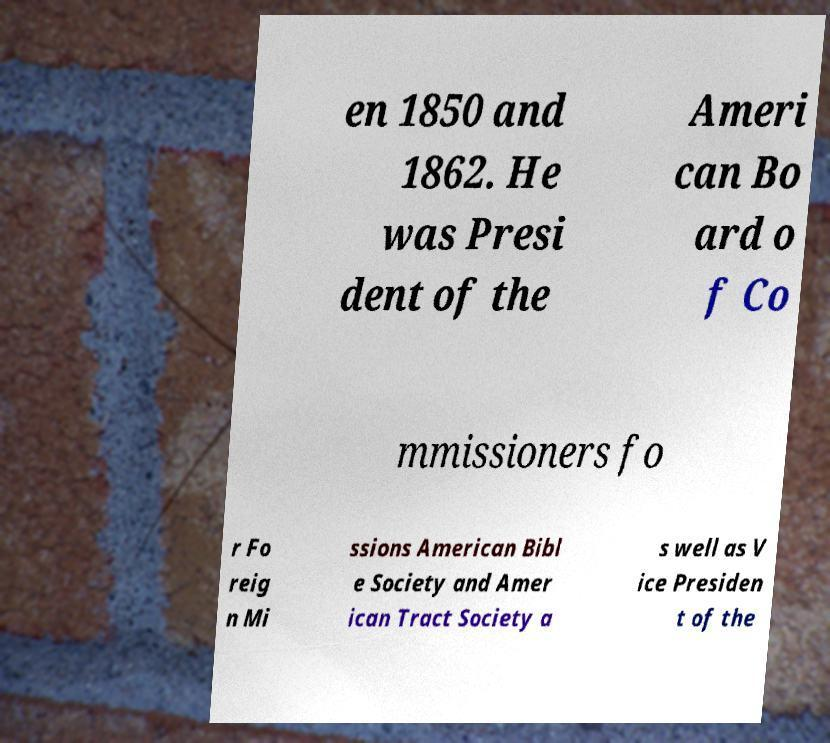Please read and relay the text visible in this image. What does it say? en 1850 and 1862. He was Presi dent of the Ameri can Bo ard o f Co mmissioners fo r Fo reig n Mi ssions American Bibl e Society and Amer ican Tract Society a s well as V ice Presiden t of the 